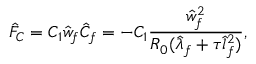Convert formula to latex. <formula><loc_0><loc_0><loc_500><loc_500>{ \hat { F } } _ { C } = C _ { 1 } \hat { w } _ { f } \hat { C } _ { f } = - C _ { 1 } \frac { \hat { w } _ { f } ^ { 2 } } { R _ { 0 } ( \hat { \lambda } _ { f } + \tau \hat { l } _ { f } ^ { 2 } ) } ,</formula> 